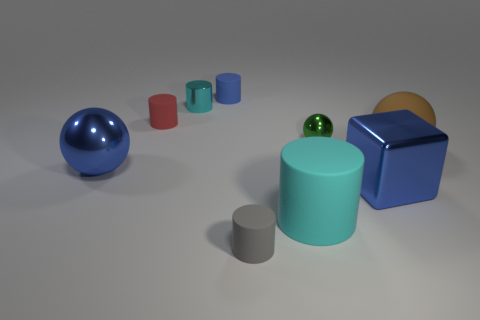Subtract all brown cylinders. Subtract all red blocks. How many cylinders are left? 5 Subtract all balls. How many objects are left? 6 Subtract 0 yellow spheres. How many objects are left? 9 Subtract all large matte cylinders. Subtract all brown things. How many objects are left? 7 Add 5 large cylinders. How many large cylinders are left? 6 Add 2 cyan cylinders. How many cyan cylinders exist? 4 